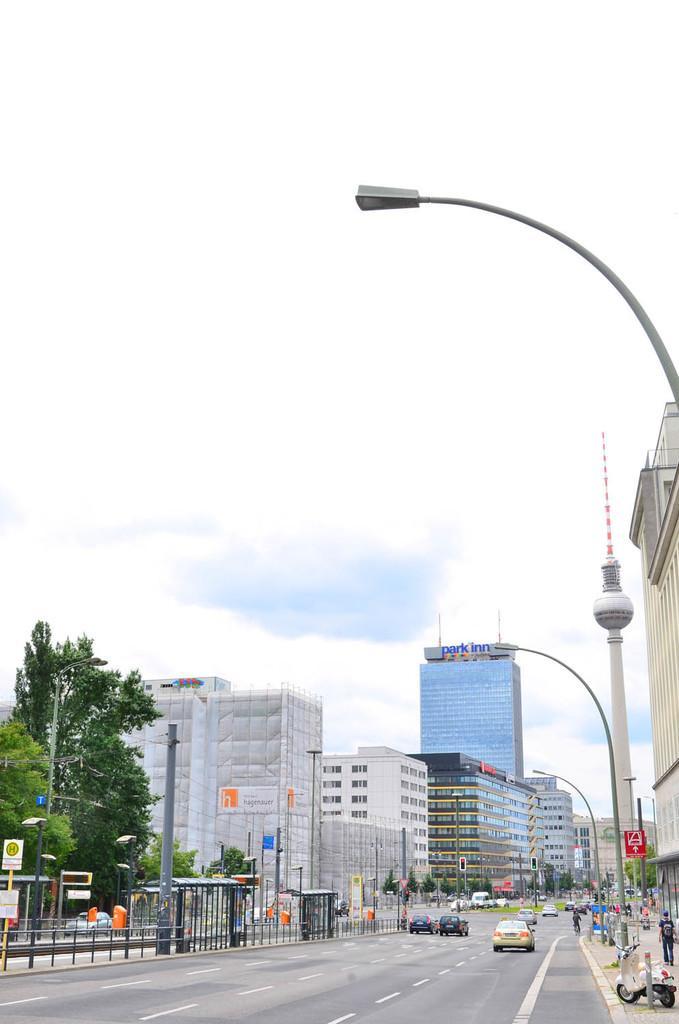Can you describe this image briefly? In this image there is a road and vehicles are moving. There are trees and buildings. There are people walking on the footpath. There is a tall pillar with a tower on the right side. There is a sky. 